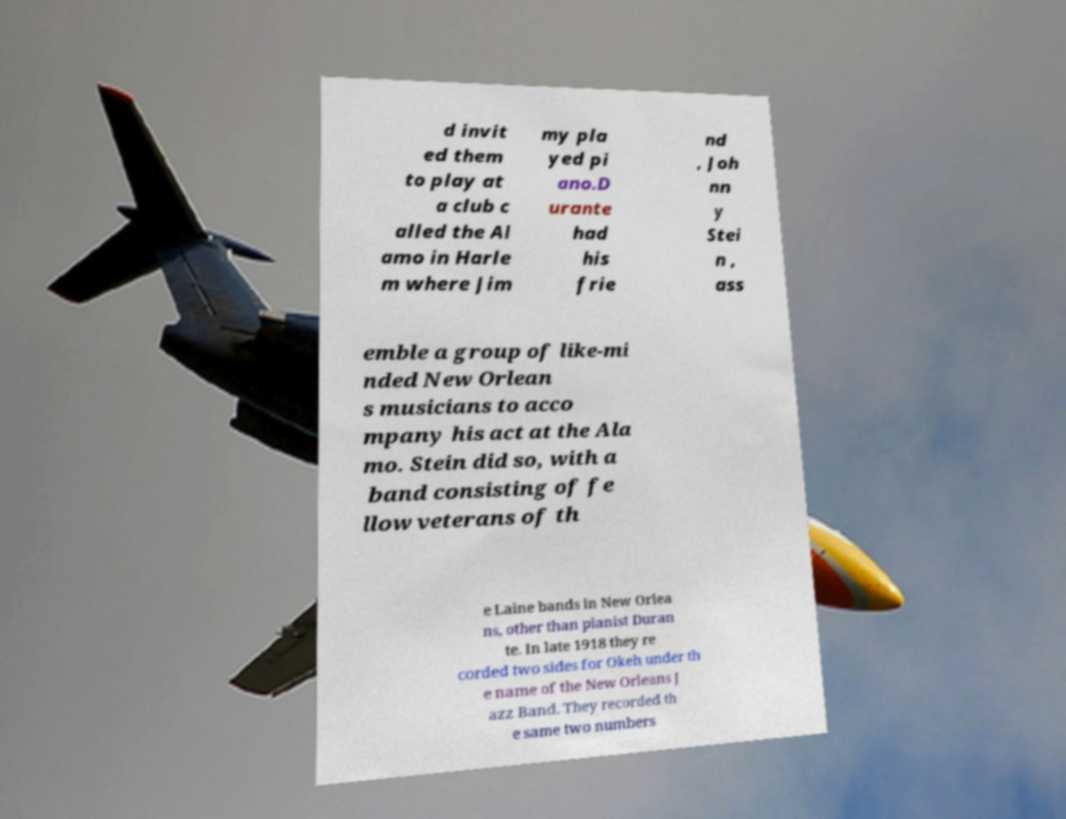Please read and relay the text visible in this image. What does it say? d invit ed them to play at a club c alled the Al amo in Harle m where Jim my pla yed pi ano.D urante had his frie nd , Joh nn y Stei n , ass emble a group of like-mi nded New Orlean s musicians to acco mpany his act at the Ala mo. Stein did so, with a band consisting of fe llow veterans of th e Laine bands in New Orlea ns, other than pianist Duran te. In late 1918 they re corded two sides for Okeh under th e name of the New Orleans J azz Band. They recorded th e same two numbers 